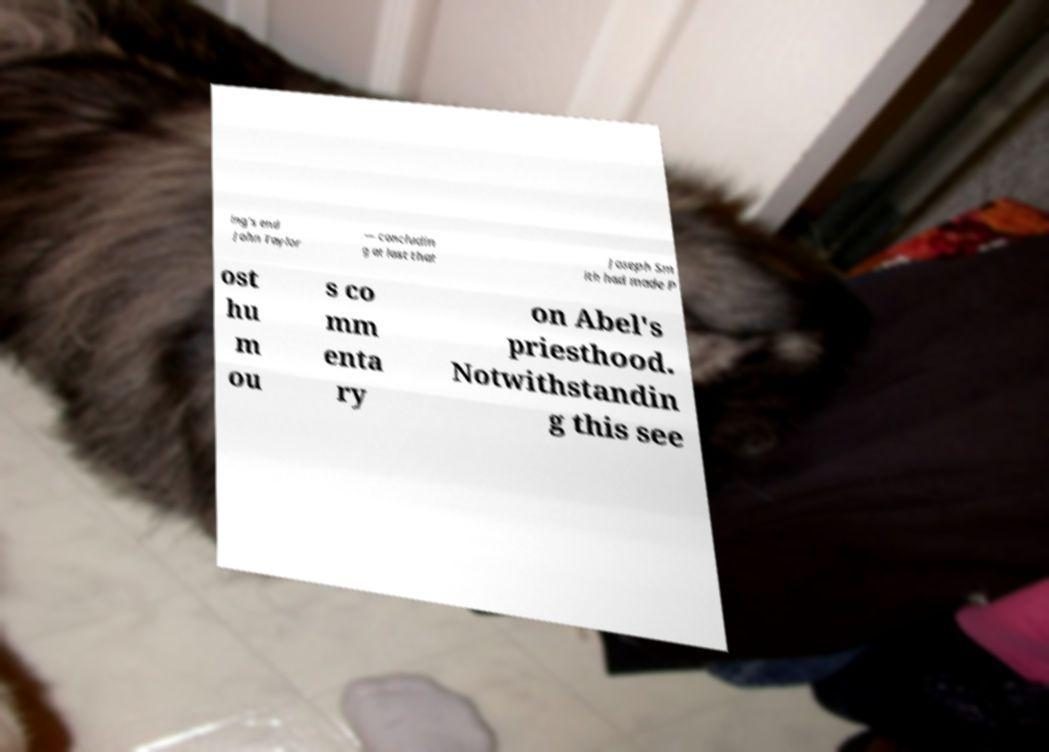Please identify and transcribe the text found in this image. ing's end John Taylor — concludin g at last that Joseph Sm ith had made P ost hu m ou s co mm enta ry on Abel's priesthood. Notwithstandin g this see 